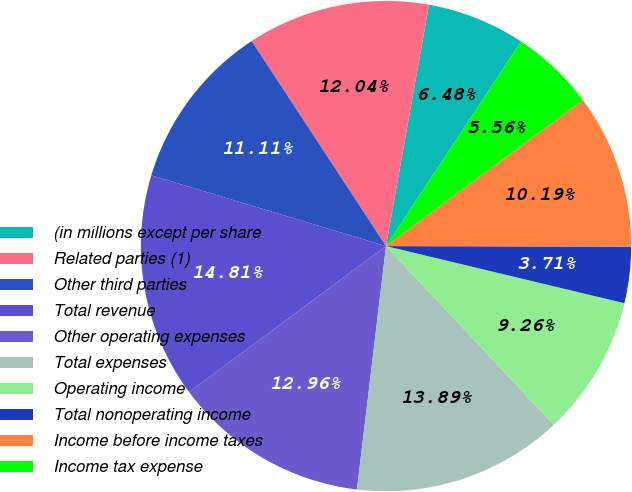Convert chart to OTSL. <chart><loc_0><loc_0><loc_500><loc_500><pie_chart><fcel>(in millions except per share<fcel>Related parties (1)<fcel>Other third parties<fcel>Total revenue<fcel>Other operating expenses<fcel>Total expenses<fcel>Operating income<fcel>Total nonoperating income<fcel>Income before income taxes<fcel>Income tax expense<nl><fcel>6.48%<fcel>12.04%<fcel>11.11%<fcel>14.81%<fcel>12.96%<fcel>13.89%<fcel>9.26%<fcel>3.71%<fcel>10.19%<fcel>5.56%<nl></chart> 